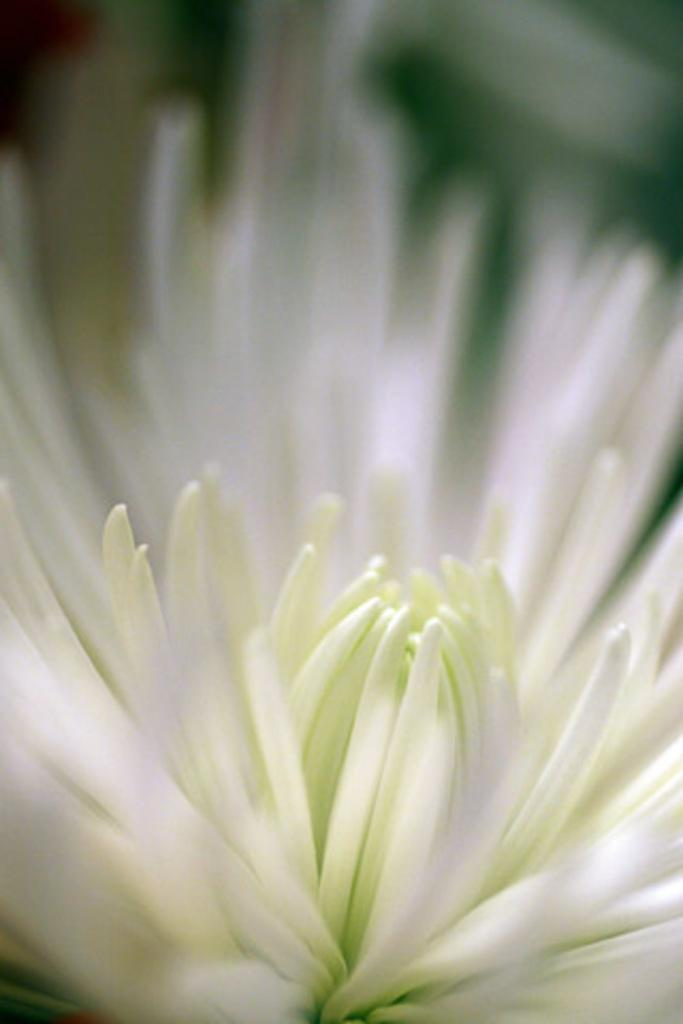What type of flower is in the image? There is a white flower in the image. Can you describe the background of the image? The background of the image is blurred. What type of skin condition can be seen on the fish in the image? There is no fish present in the image, and therefore no skin condition can be observed. 